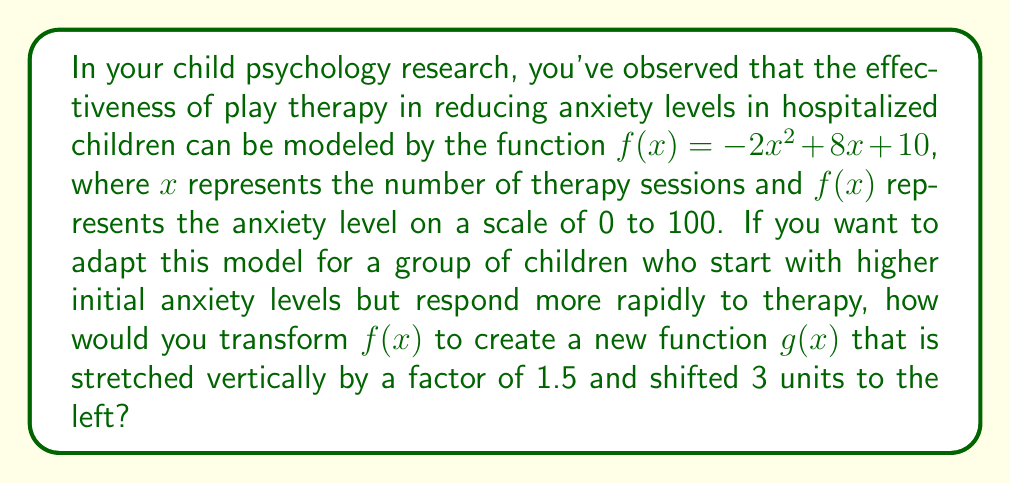Give your solution to this math problem. To transform the original function $f(x) = -2x^2 + 8x + 10$ into the new function $g(x)$, we need to apply two transformations:

1. Vertical stretch by a factor of 1.5:
   This transformation multiplies the entire function by 1.5.
   $f(x) \rightarrow 1.5f(x) = 1.5(-2x^2 + 8x + 10) = -3x^2 + 12x + 15$

2. Horizontal shift 3 units to the left:
   This transformation replaces every $x$ with $(x+3)$.
   $-3x^2 + 12x + 15 \rightarrow -3(x+3)^2 + 12(x+3) + 15$

Now, let's expand the squared term:
$g(x) = -3(x^2 + 6x + 9) + 12x + 36 + 15$
$g(x) = -3x^2 - 18x - 27 + 12x + 36 + 15$
$g(x) = -3x^2 - 6x + 24$

Therefore, the new function $g(x)$ that represents the adapted model is:
$g(x) = -3x^2 - 6x + 24$
Answer: $g(x) = -3x^2 - 6x + 24$ 